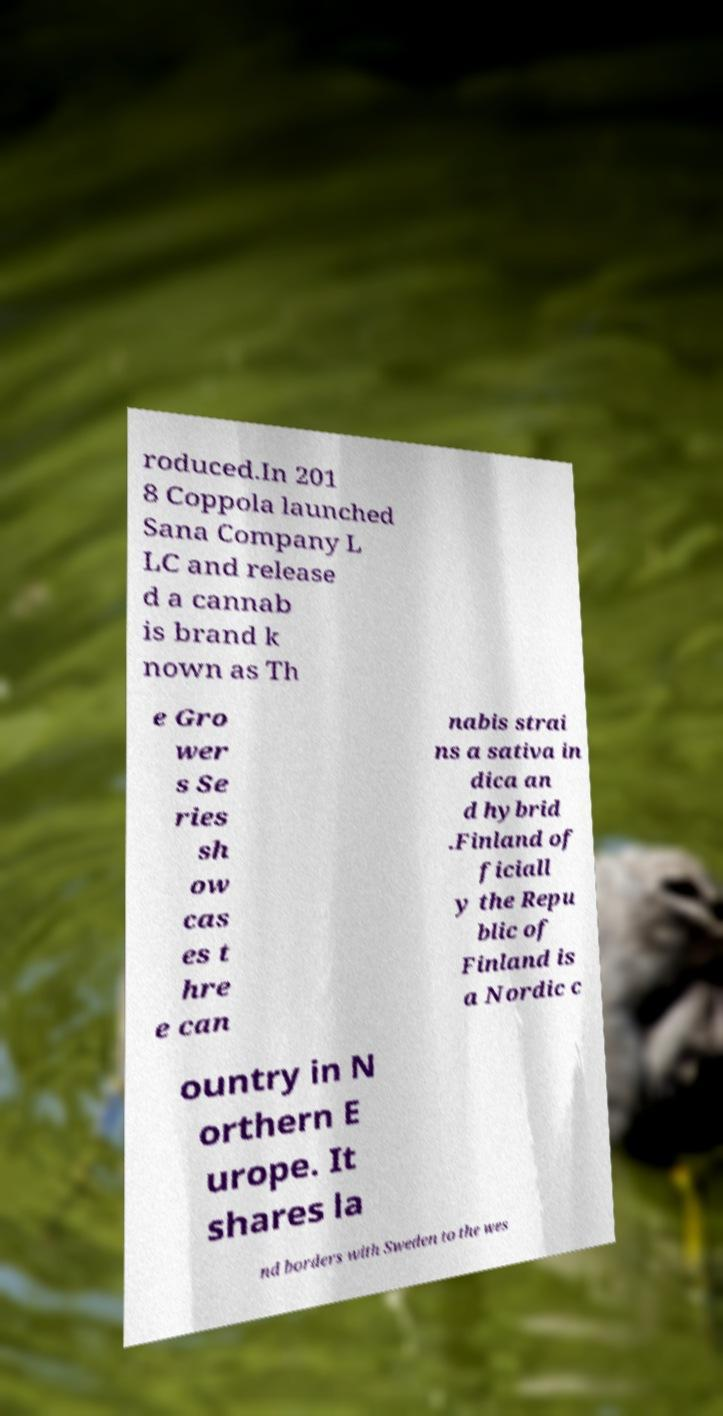I need the written content from this picture converted into text. Can you do that? roduced.In 201 8 Coppola launched Sana Company L LC and release d a cannab is brand k nown as Th e Gro wer s Se ries sh ow cas es t hre e can nabis strai ns a sativa in dica an d hybrid .Finland of ficiall y the Repu blic of Finland is a Nordic c ountry in N orthern E urope. It shares la nd borders with Sweden to the wes 